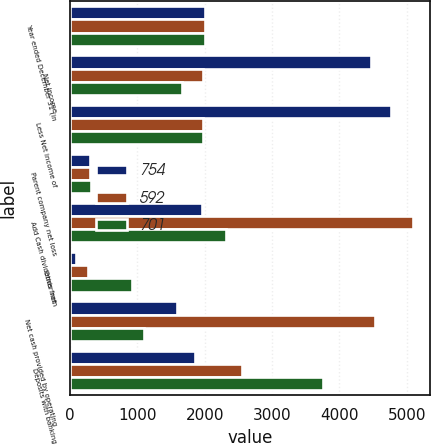Convert chart. <chart><loc_0><loc_0><loc_500><loc_500><stacked_bar_chart><ecel><fcel>Year ended December 31 (in<fcel>Net income<fcel>Less Net income of<fcel>Parent company net loss<fcel>Add Cash dividends from<fcel>Other net<fcel>Net cash provided by operating<fcel>Deposits with banking<nl><fcel>754<fcel>2004<fcel>4466<fcel>4762<fcel>296<fcel>1964<fcel>81<fcel>1587<fcel>1851<nl><fcel>592<fcel>2003<fcel>1967.5<fcel>1967.5<fcel>298<fcel>5098<fcel>272<fcel>4528<fcel>2560<nl><fcel>701<fcel>2002<fcel>1663<fcel>1971<fcel>308<fcel>2320<fcel>912<fcel>1100<fcel>3755<nl></chart> 